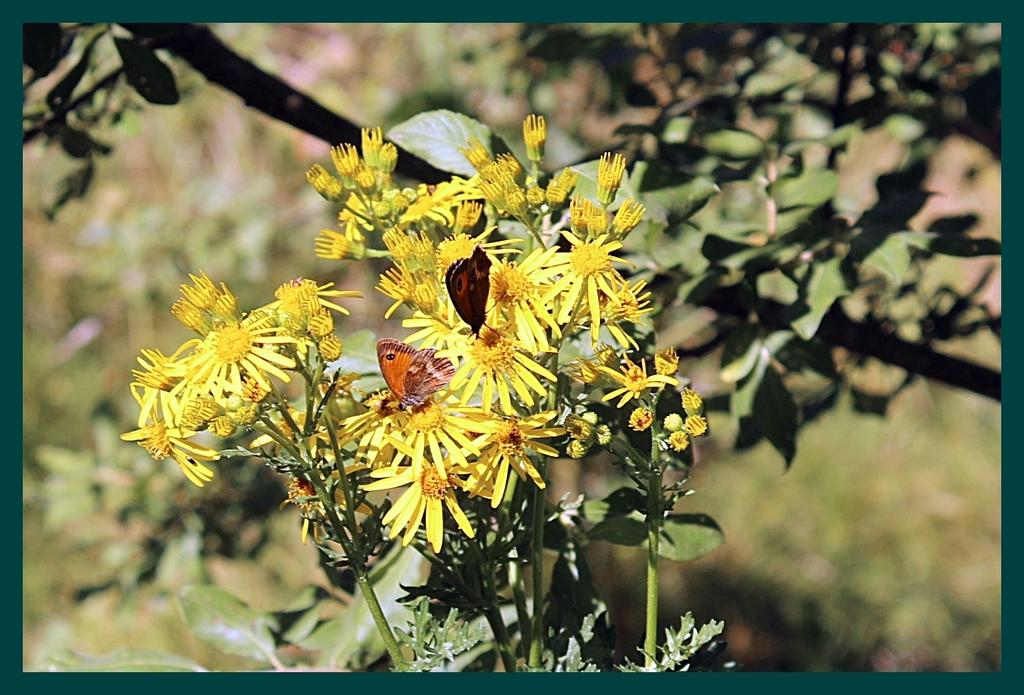How many butterflies can be seen in the image? There are two butterflies in the image. What are the butterflies doing in the image? The butterflies are on flowers in the image. What other living organisms can be seen in the image? There are plants in the image. Can you describe the background of the image? The background of the image is blurry. What type of rifle can be seen in the image? There is no rifle present in the image; it features two butterflies on flowers. What news headline is visible in the image? There is no news headline present in the image; it is a photograph of butterflies on flowers. 